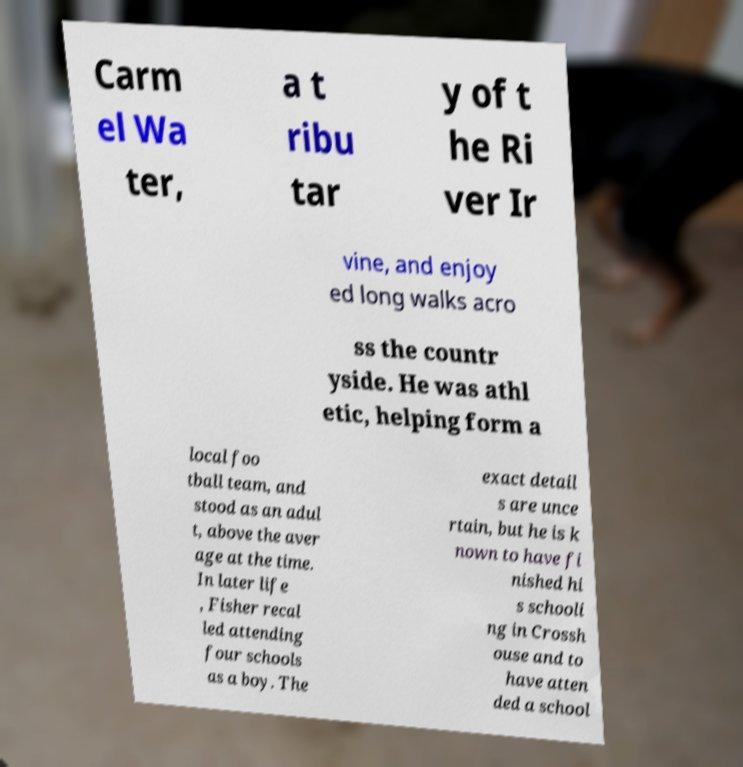I need the written content from this picture converted into text. Can you do that? Carm el Wa ter, a t ribu tar y of t he Ri ver Ir vine, and enjoy ed long walks acro ss the countr yside. He was athl etic, helping form a local foo tball team, and stood as an adul t, above the aver age at the time. In later life , Fisher recal led attending four schools as a boy. The exact detail s are unce rtain, but he is k nown to have fi nished hi s schooli ng in Crossh ouse and to have atten ded a school 